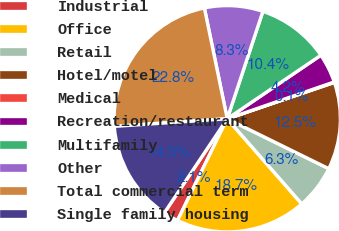Convert chart. <chart><loc_0><loc_0><loc_500><loc_500><pie_chart><fcel>Industrial<fcel>Office<fcel>Retail<fcel>Hotel/motel<fcel>Medical<fcel>Recreation/restaurant<fcel>Multifamily<fcel>Other<fcel>Total commercial term<fcel>Single family housing<nl><fcel>2.14%<fcel>18.69%<fcel>6.28%<fcel>12.48%<fcel>0.07%<fcel>4.21%<fcel>10.41%<fcel>8.34%<fcel>22.83%<fcel>14.55%<nl></chart> 